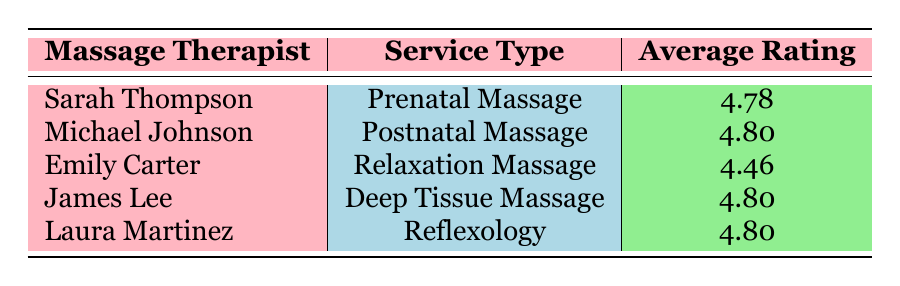What is the average rating for Sarah Thompson? Sarah Thompson's average rating is directly listed in the table under "Average Rating," which is 4.78.
Answer: 4.78 Which massage therapist has the highest average rating? The table shows that both Michael Johnson and Laura Martinez have an average rating of 4.80, which is the highest.
Answer: Michael Johnson and Laura Martinez Is Emily Carter's average rating above 4.5? Emily Carter's average rating is listed as 4.46. Since 4.46 is less than 4.5, the answer is NO.
Answer: No What is the difference between the average ratings of Deep Tissue Massage and Relaxation Massage? The average rating for Deep Tissue Massage (James Lee) is 4.80, and for Relaxation Massage (Emily Carter) it is 4.46. To find the difference, we subtract 4.46 from 4.80, which gives us 0.34.
Answer: 0.34 How many massage therapists have an average rating of 4.8 or higher? The average ratings of the therapists are 4.78 (Sarah Thompson), 4.80 (Michael Johnson), 4.80 (James Lee), and 4.80 (Laura Martinez). Counting these, we find there are 4 therapists with ratings of 4.8 or higher.
Answer: 4 Which service type has the lowest average rating? Looking at the average ratings in the table, the Relaxation Massage, provided by Emily Carter, has the lowest average rating of 4.46.
Answer: Relaxation Massage Is it true that all massage therapists have ratings above 4.5? By checking each therapist's average rating, we find that they are all above 4.5. Therefore, the statement is true.
Answer: Yes Calculate the average of all average ratings listed in the table. The average ratings are: 4.78 (Sarah Thompson), 4.80 (Michael Johnson), 4.46 (Emily Carter), 4.80 (James Lee), and 4.80 (Laura Martinez). Adding them together gives 4.78 + 4.80 + 4.46 + 4.80 + 4.80 = 24.64. Dividing by 5 gives 24.64 / 5 = 4.928.
Answer: 4.928 What service type does Sarah Thompson provide? The table lists Sarah Thompson under "Service Type" as providing a Prenatal Massage.
Answer: Prenatal Massage 